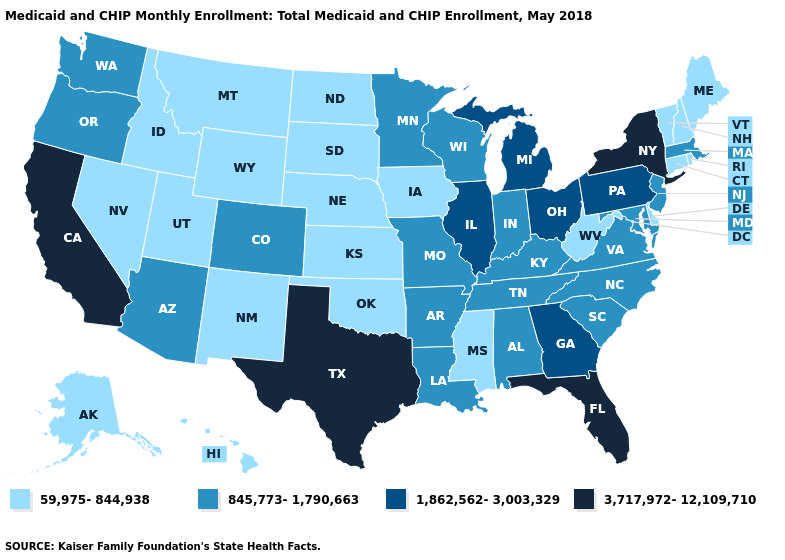Among the states that border Rhode Island , which have the highest value?
Answer briefly. Massachusetts. Which states have the highest value in the USA?
Quick response, please. California, Florida, New York, Texas. Does California have the highest value in the West?
Give a very brief answer. Yes. What is the highest value in the USA?
Write a very short answer. 3,717,972-12,109,710. Which states have the lowest value in the MidWest?
Answer briefly. Iowa, Kansas, Nebraska, North Dakota, South Dakota. What is the value of Florida?
Quick response, please. 3,717,972-12,109,710. Name the states that have a value in the range 1,862,562-3,003,329?
Write a very short answer. Georgia, Illinois, Michigan, Ohio, Pennsylvania. Which states have the lowest value in the South?
Be succinct. Delaware, Mississippi, Oklahoma, West Virginia. What is the value of Georgia?
Keep it brief. 1,862,562-3,003,329. Among the states that border Alabama , does Mississippi have the lowest value?
Keep it brief. Yes. Among the states that border Tennessee , does Georgia have the highest value?
Keep it brief. Yes. What is the value of Massachusetts?
Be succinct. 845,773-1,790,663. Name the states that have a value in the range 845,773-1,790,663?
Answer briefly. Alabama, Arizona, Arkansas, Colorado, Indiana, Kentucky, Louisiana, Maryland, Massachusetts, Minnesota, Missouri, New Jersey, North Carolina, Oregon, South Carolina, Tennessee, Virginia, Washington, Wisconsin. What is the lowest value in the West?
Keep it brief. 59,975-844,938. 